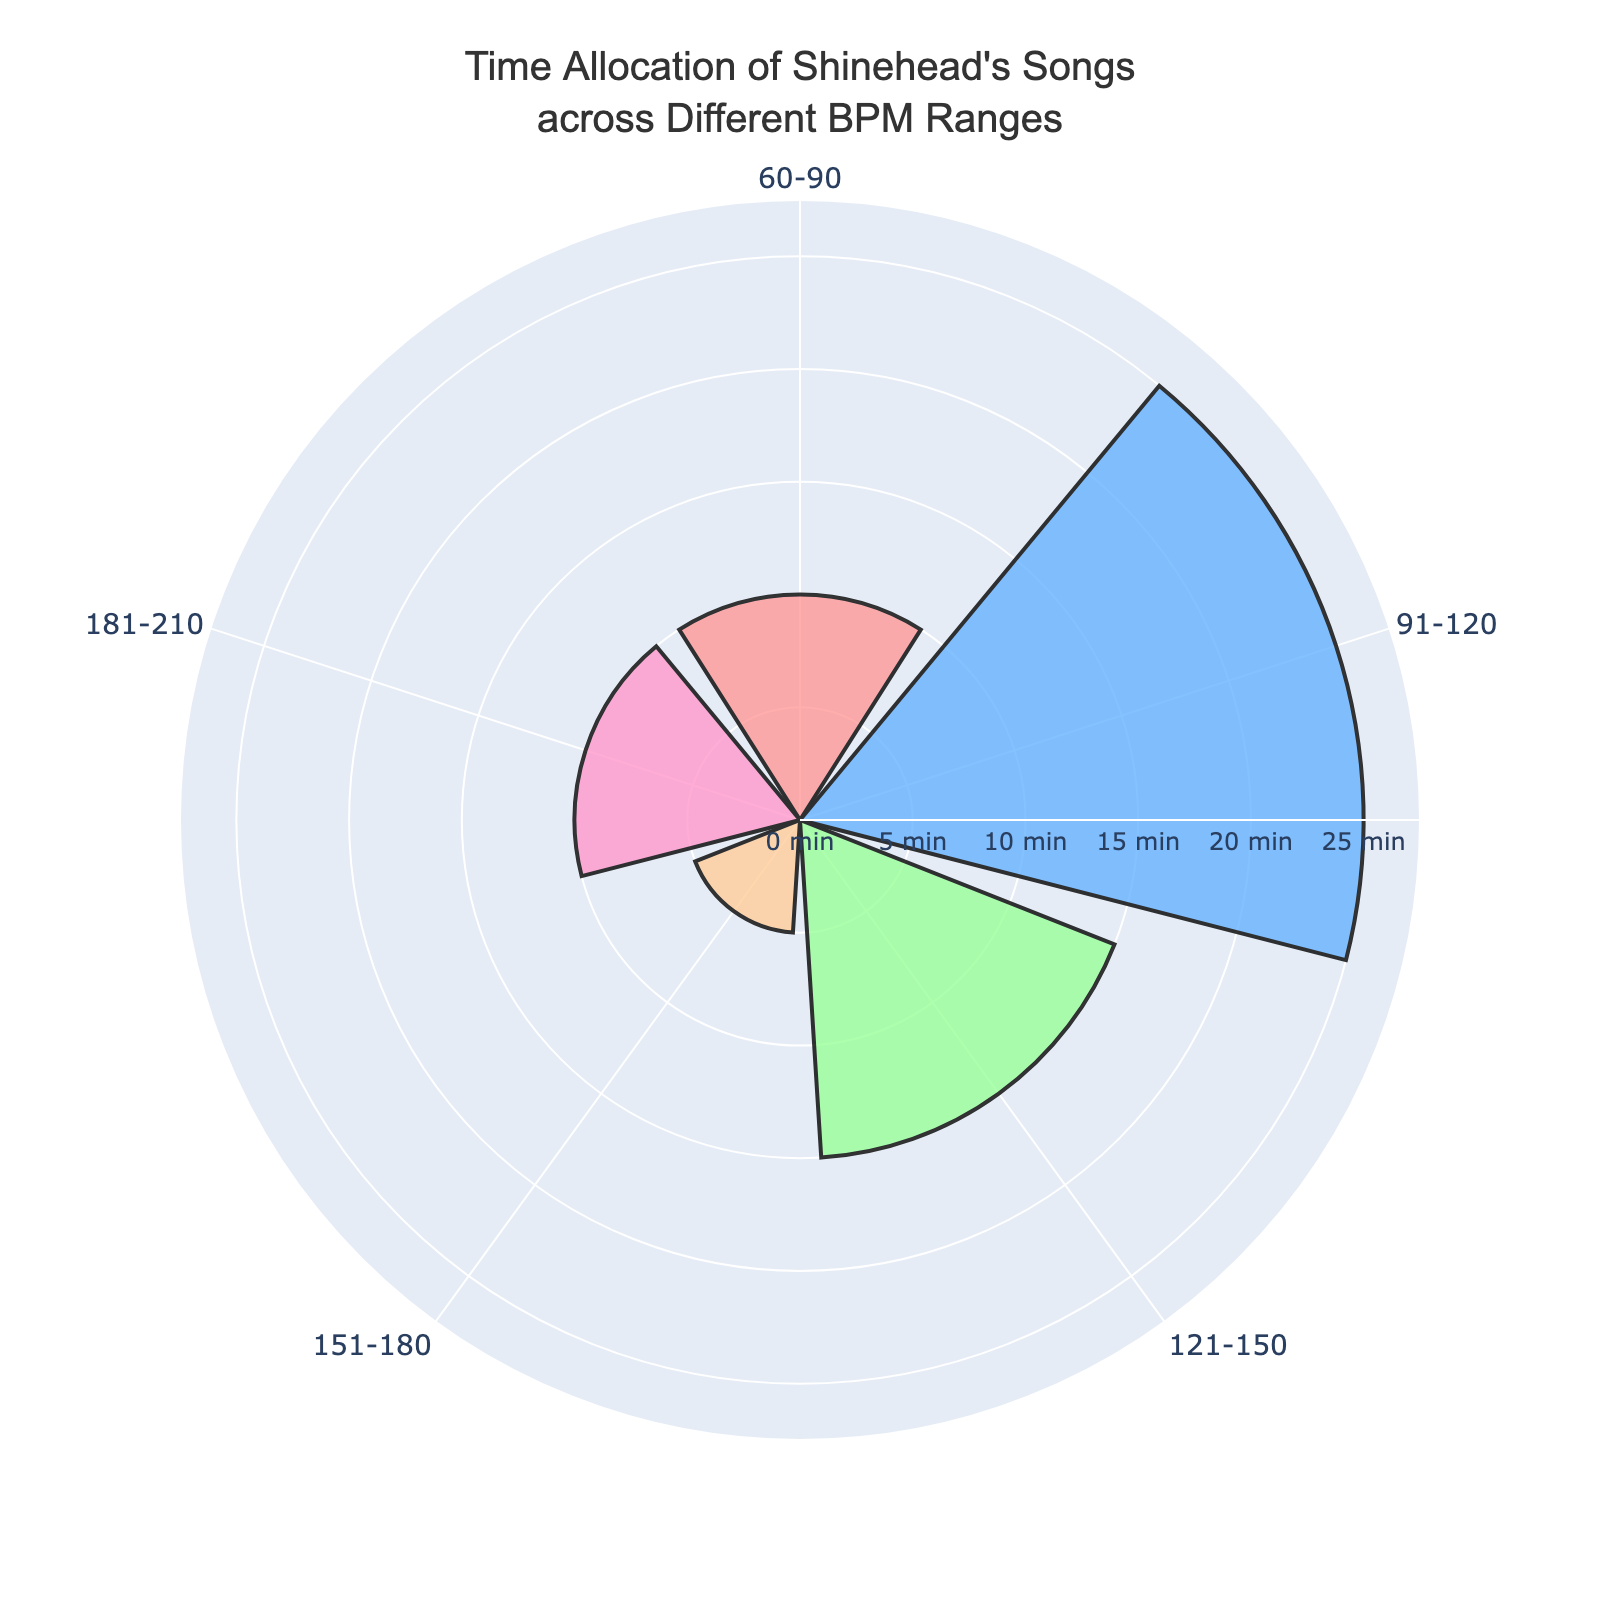What's the title of the figure? The title is usually displayed prominently at the top of the chart. In this case, it says "Time Allocation of Shinehead's Songs across Different BPM Ranges".
Answer: Time Allocation of Shinehead's Songs across Different BPM Ranges How many BPM ranges are displayed in the chart? Each segment with labels around the chart represents a BPM range. By counting these segments, you can see there are 5 BPM ranges displayed.
Answer: 5 Which BPM range has the highest total time allocation? The largest segment visually represents the BPM range with the highest total time allocation. This corresponds to the 91-120 BPM range.
Answer: 91-120 BPM What is the total time allocation for the 121-150 BPM range? By looking at the size of the segments and reading the labels, you can see the 121-150 BPM range has a total time allocation of 15 minutes.
Answer: 15 minutes How does the total time for the 60-90 BPM range compare to the 151-180 BPM range? Comparing the two segments showing these ranges, the 60-90 BPM range, with a total of 10 minutes, is larger than the 151-180 BPM range, which has a total of 5 minutes.
Answer: 60-90 BPM range has double the time allocation of the 151-180 BPM range What is the combined total time for all BPM ranges? To find the combined total time, sum the time allocations from all BPM ranges: 10 (60-90) + 25 (91-120) + 15 (121-150) + 5 (151-180) + 10 (181-210) = 65 minutes.
Answer: 65 minutes Which two BPM ranges have an equal total time allocation? By observing the chart, the 60-90 BPM and 181-210 BPM ranges each have a total time allocation of 10 minutes.
Answer: 60-90 BPM and 181-210 BPM What is the average total time allocation across all BPM ranges? First, find the combined total time (65 minutes) and the number of BPM ranges (5). The average is then 65 divided by 5, which equals 13 minutes.
Answer: 13 minutes What is the difference in total time allocation between the range with the highest and lowest time allocations? The highest time allocation is for the 91-120 BPM range with 25 minutes, and the lowest is for the 151-180 BPM range with 5 minutes. The difference is 25 - 5 = 20 minutes.
Answer: 20 minutes 